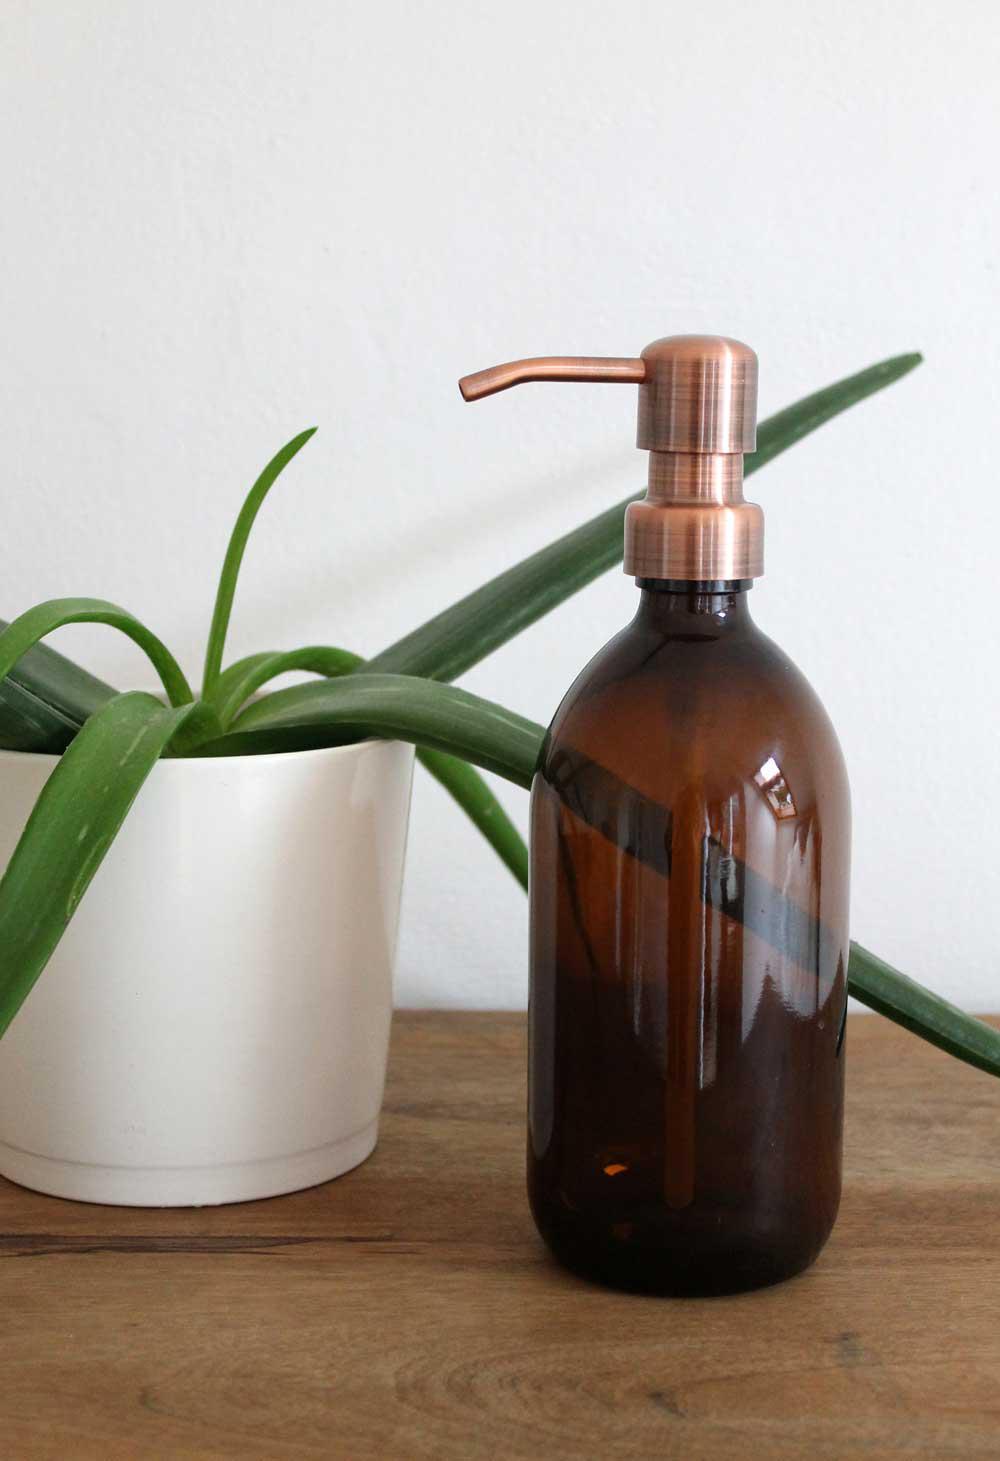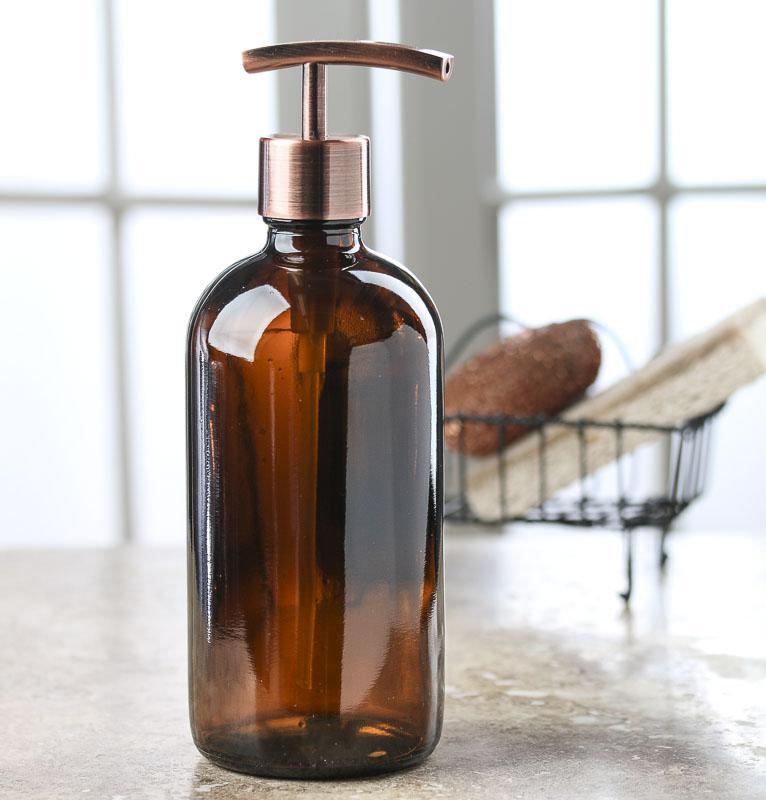The first image is the image on the left, the second image is the image on the right. Evaluate the accuracy of this statement regarding the images: "The nozzle of the dispenser in the right image is pointed towards the right.". Is it true? Answer yes or no. Yes. The first image is the image on the left, the second image is the image on the right. For the images shown, is this caption "There is a plant to the left of one of the bottles, and one of the bottles is on a wooden surface." true? Answer yes or no. Yes. 